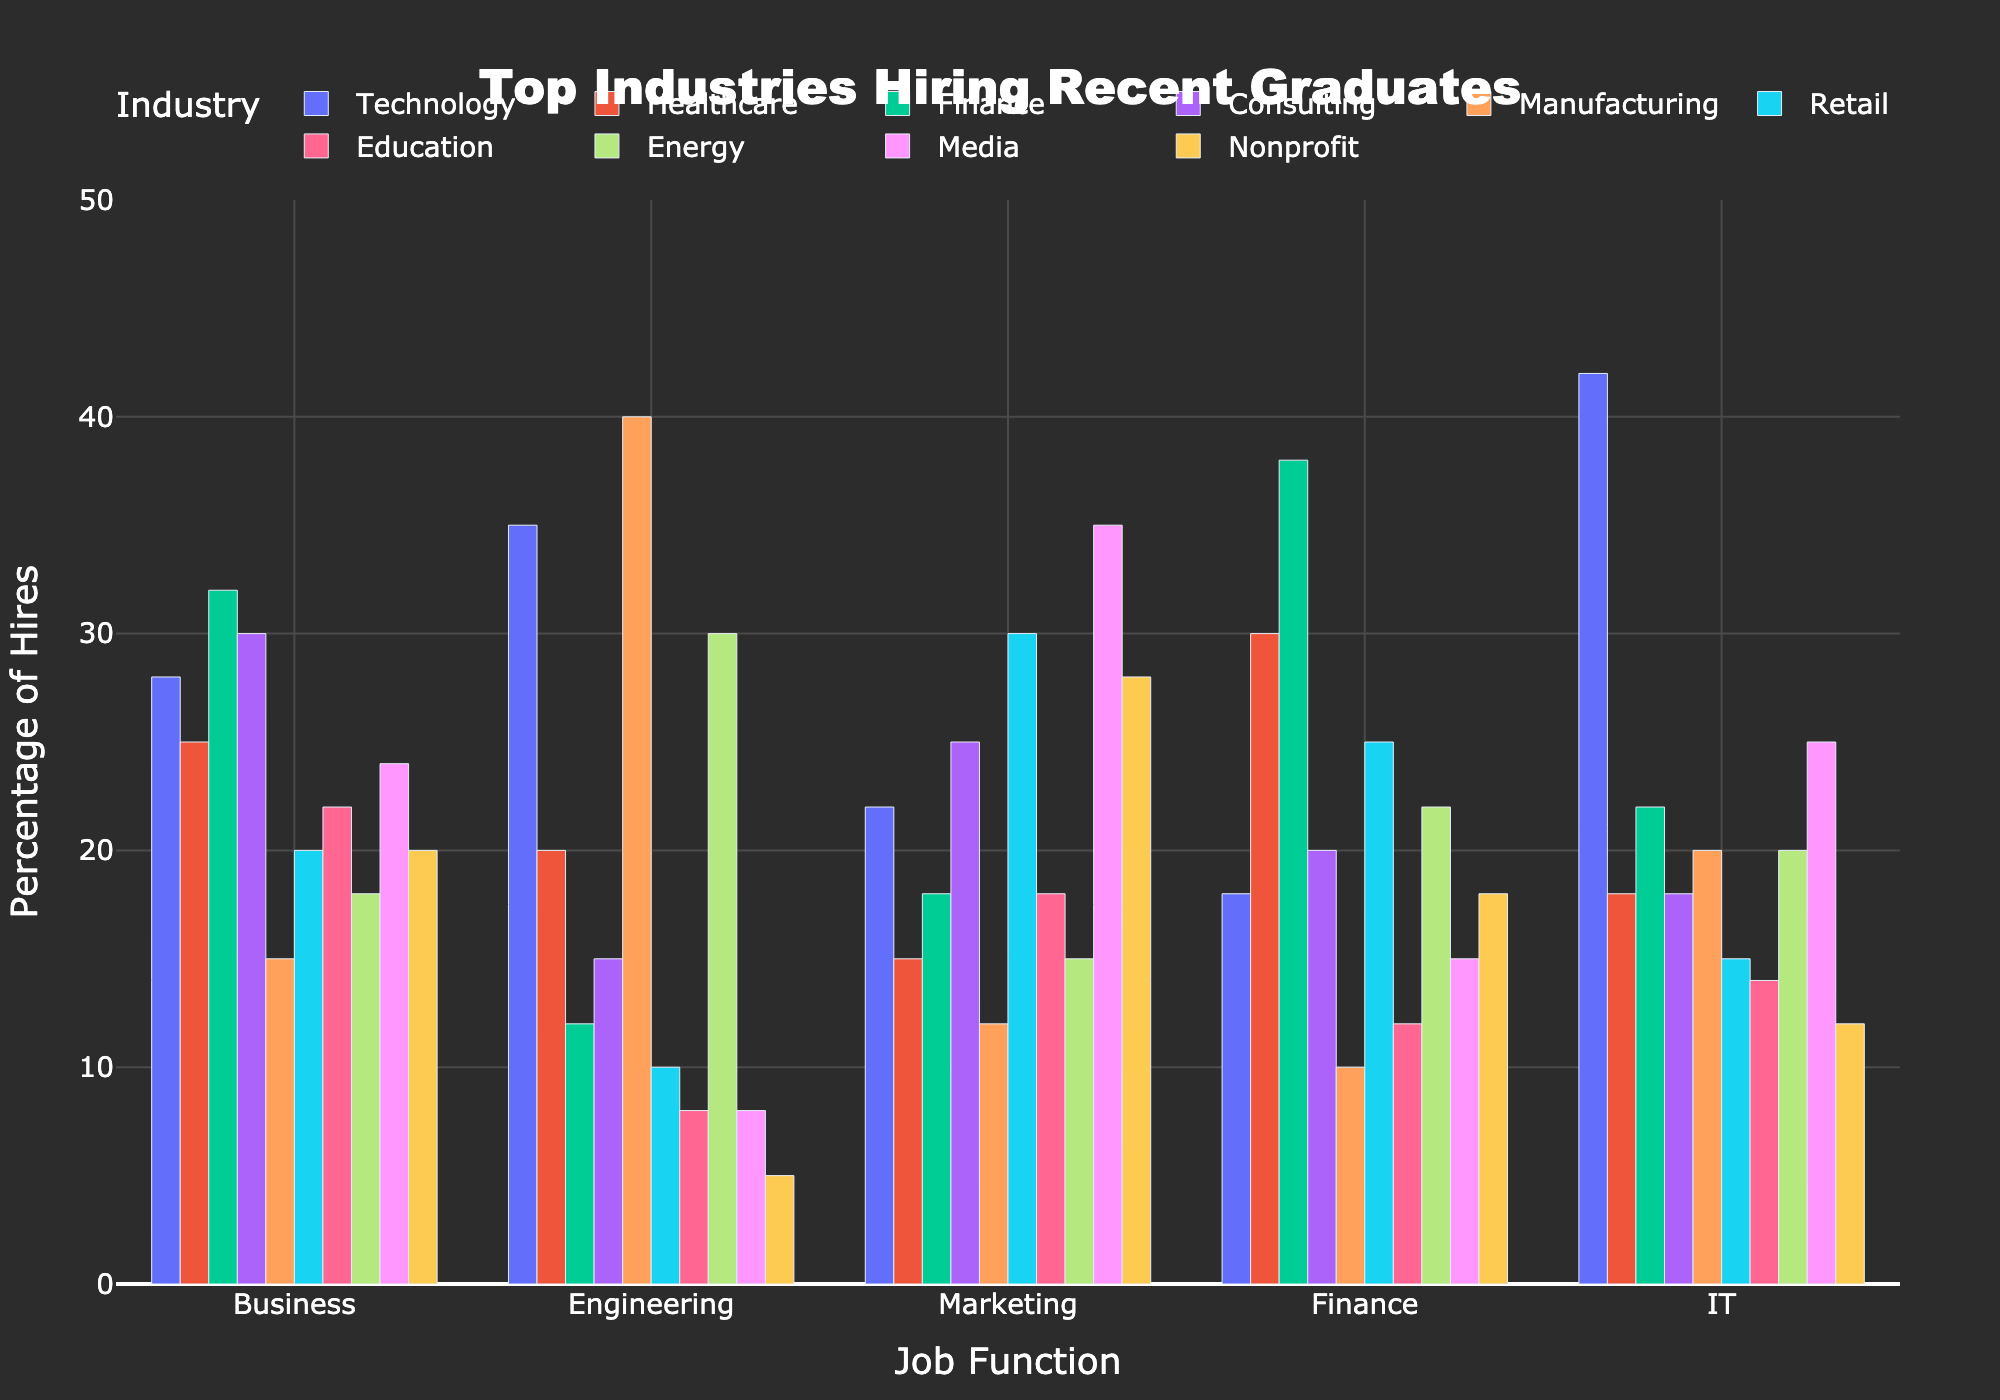What's the top industry hiring for the Finance job function? Scan through the bars under the Finance job function and identify the tallest one, which corresponds to the industry with the highest percentage of hires.
Answer: Finance Which job function has the lowest percentage of hires in the Manufacturing industry? Look at the bars corresponding to the Manufacturing industry and find the shortest one. This indicates the job function with the lowest hiring percentage.
Answer: Finance What's the total percentage of Engineering hires across Technology and Manufacturing industries? Sum the percentages of Engineering hires in Technology (35%) and Manufacturing (40%). 35 + 40 = 75
Answer: 75 How do Marketing hires compare between Retail and Media industries? Compare the bar heights for Marketing under Retail and Media. Retail has 30%, Media has 35%, so Media is higher.
Answer: Media is higher Which job function has the greatest spread in hiring percentages across industries? Assess the range of percentages for each job function across all industries. Marketing, for example, ranges from 12% in Manufacturing to 35% in Media, showing a wide spread.
Answer: Marketing What's the difference in IT hires between the Technology and Healthcare industries? Subtract the percentage of IT hires in Healthcare (18%) from the percentage in Technology (42%). 42 - 18 = 24
Answer: 24 Which industry has the closest hiring percentages across different job functions? Find the industry where the bars have the smallest height differences across the job functions. Healthcare has relatively balanced hiring percentages across the job functions.
Answer: Healthcare Sum the percentages of Nonprofit hires for Business and Marketing job functions. Add the percentages of Business (20%) and Marketing (28%) hires in the Nonprofit industry. 20 + 28 = 48
Answer: 48 Identify the industry with the lowest percentage for any job function and specify that job function. Healthcare has 8% for Education, which is the lowest percentage for any job function across industries.
Answer: Education in Healthcare 